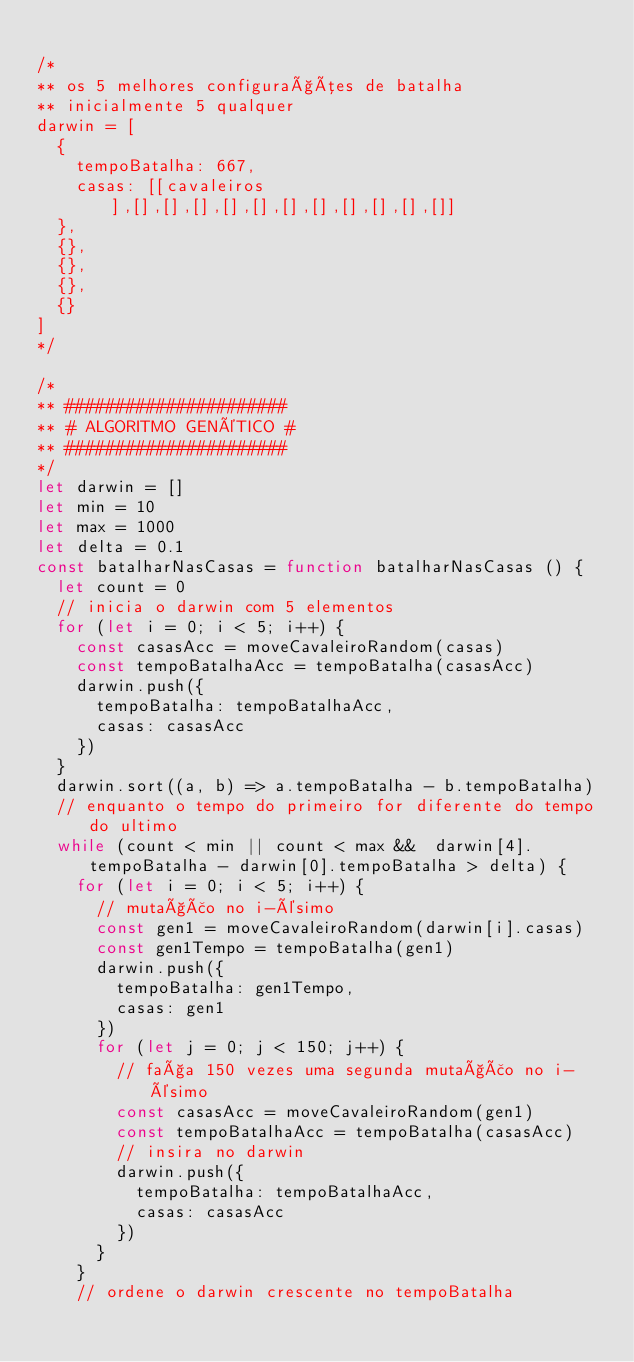Convert code to text. <code><loc_0><loc_0><loc_500><loc_500><_JavaScript_>
/*
** os 5 melhores configurações de batalha
** inicialmente 5 qualquer
darwin = [
  {
    tempoBatalha: 667,
    casas: [[cavaleiros],[],[],[],[],[],[],[],[],[],[],[]]
  },
  {},
  {},
  {},
  {}
]
*/

/*
** ######################
** # ALGORITMO GENéTICO #
** ######################
*/
let darwin = []
let min = 10
let max = 1000
let delta = 0.1
const batalharNasCasas = function batalharNasCasas () {
  let count = 0
  // inicia o darwin com 5 elementos
  for (let i = 0; i < 5; i++) {
    const casasAcc = moveCavaleiroRandom(casas)
    const tempoBatalhaAcc = tempoBatalha(casasAcc)
    darwin.push({
      tempoBatalha: tempoBatalhaAcc,
      casas: casasAcc
    })
  }
  darwin.sort((a, b) => a.tempoBatalha - b.tempoBatalha)
  // enquanto o tempo do primeiro for diferente do tempo do ultimo
  while (count < min || count < max &&  darwin[4].tempoBatalha - darwin[0].tempoBatalha > delta) {
    for (let i = 0; i < 5; i++) {
      // mutação no i-ésimo
      const gen1 = moveCavaleiroRandom(darwin[i].casas)
      const gen1Tempo = tempoBatalha(gen1)
      darwin.push({
        tempoBatalha: gen1Tempo,
        casas: gen1
      })
      for (let j = 0; j < 150; j++) {
        // faça 150 vezes uma segunda mutação no i-ésimo
        const casasAcc = moveCavaleiroRandom(gen1)
        const tempoBatalhaAcc = tempoBatalha(casasAcc)
        // insira no darwin
        darwin.push({
          tempoBatalha: tempoBatalhaAcc,
          casas: casasAcc
        })
      }
    }
    // ordene o darwin crescente no tempoBatalha</code> 